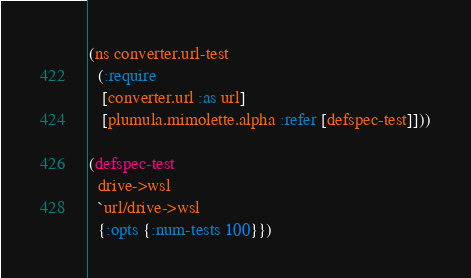Convert code to text. <code><loc_0><loc_0><loc_500><loc_500><_Clojure_>(ns converter.url-test
  (:require
   [converter.url :as url]
   [plumula.mimolette.alpha :refer [defspec-test]]))

(defspec-test
  drive->wsl
  `url/drive->wsl
  {:opts {:num-tests 100}})
</code> 